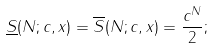Convert formula to latex. <formula><loc_0><loc_0><loc_500><loc_500>\underline { S } ( N ; c , x ) = \overline { S } ( N ; c , x ) = \frac { c ^ { N } } { 2 } ;</formula> 